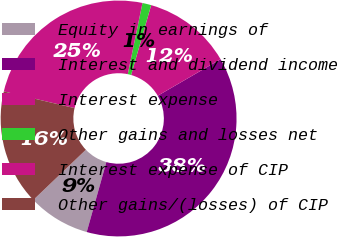Convert chart. <chart><loc_0><loc_0><loc_500><loc_500><pie_chart><fcel>Equity in earnings of<fcel>Interest and dividend income<fcel>Interest expense<fcel>Other gains and losses net<fcel>Interest expense of CIP<fcel>Other gains/(losses) of CIP<nl><fcel>8.51%<fcel>37.73%<fcel>12.17%<fcel>1.21%<fcel>24.56%<fcel>15.82%<nl></chart> 